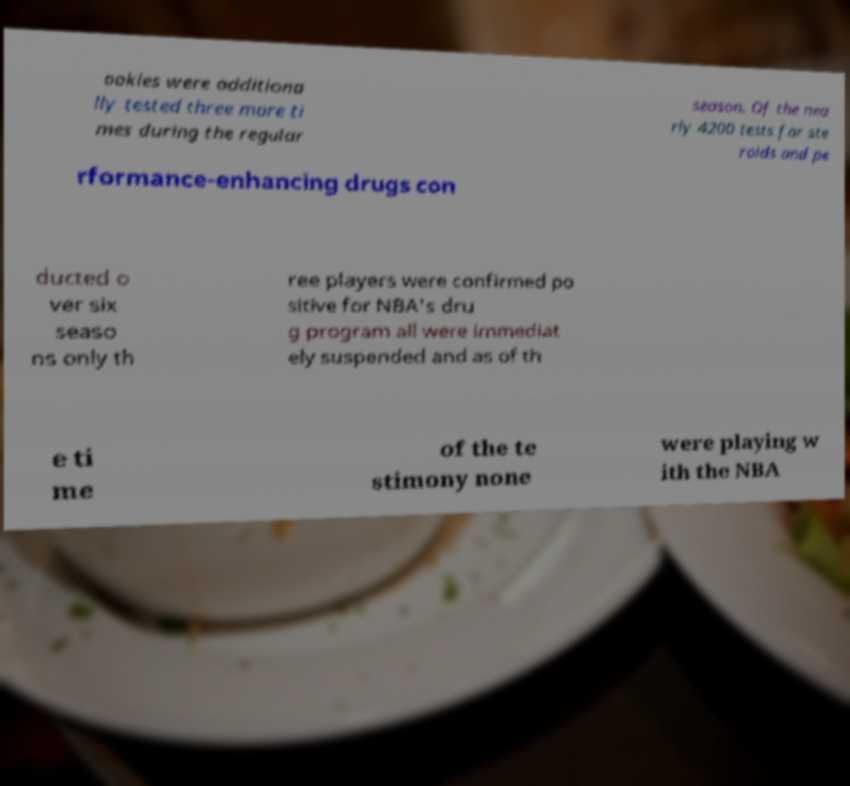Can you read and provide the text displayed in the image?This photo seems to have some interesting text. Can you extract and type it out for me? ookies were additiona lly tested three more ti mes during the regular season. Of the nea rly 4200 tests for ste roids and pe rformance-enhancing drugs con ducted o ver six seaso ns only th ree players were confirmed po sitive for NBA's dru g program all were immediat ely suspended and as of th e ti me of the te stimony none were playing w ith the NBA 